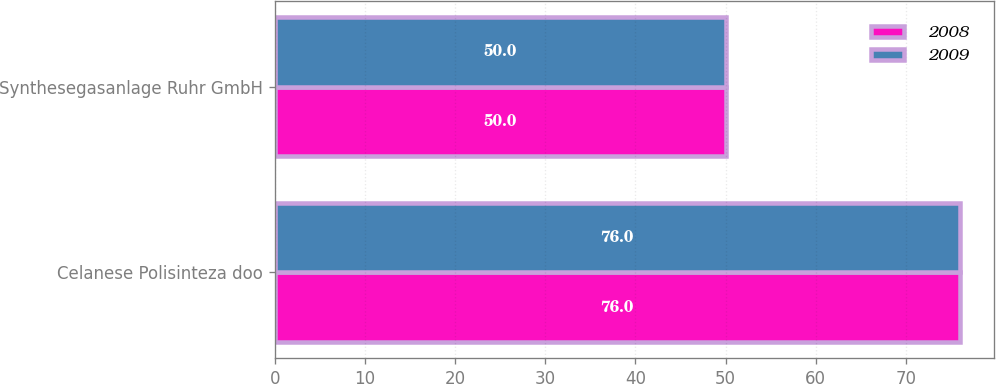<chart> <loc_0><loc_0><loc_500><loc_500><stacked_bar_chart><ecel><fcel>Celanese Polisinteza doo<fcel>Synthesegasanlage Ruhr GmbH<nl><fcel>2008<fcel>76<fcel>50<nl><fcel>2009<fcel>76<fcel>50<nl></chart> 